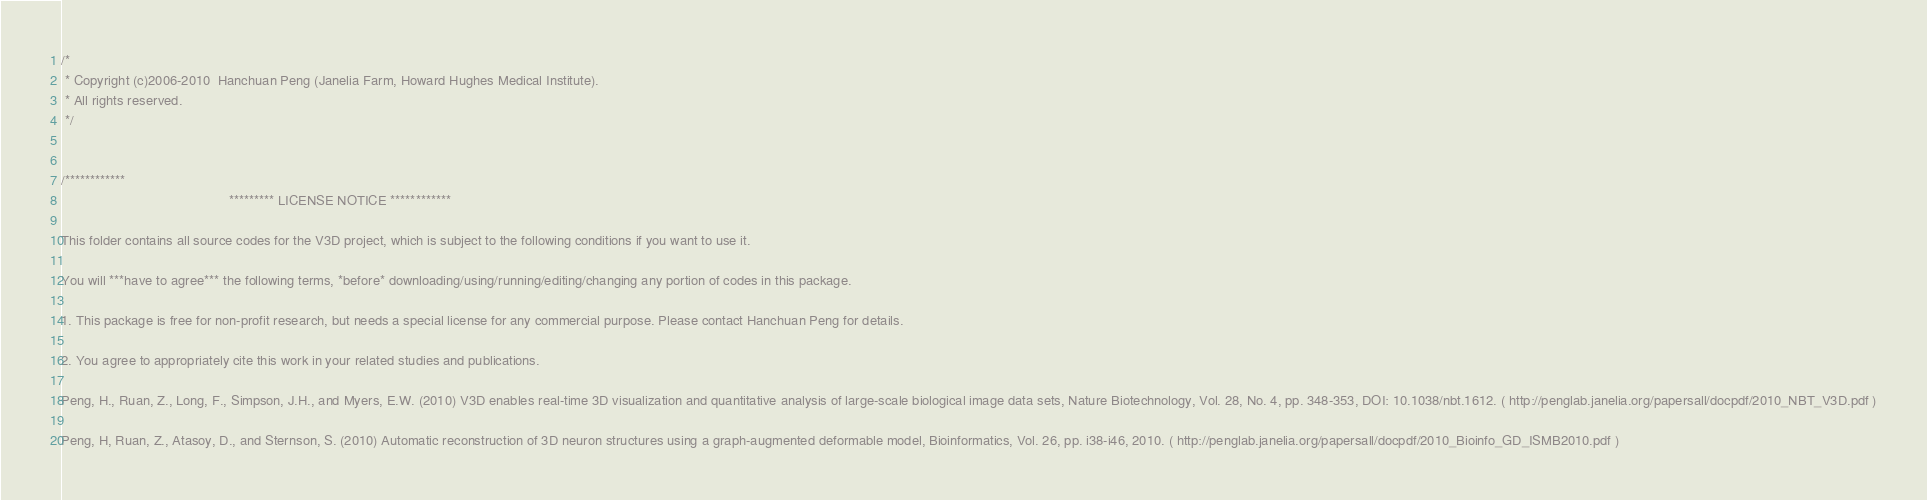<code> <loc_0><loc_0><loc_500><loc_500><_C_>/*
 * Copyright (c)2006-2010  Hanchuan Peng (Janelia Farm, Howard Hughes Medical Institute).
 * All rights reserved.
 */


/************
                                            ********* LICENSE NOTICE ************

This folder contains all source codes for the V3D project, which is subject to the following conditions if you want to use it.

You will ***have to agree*** the following terms, *before* downloading/using/running/editing/changing any portion of codes in this package.

1. This package is free for non-profit research, but needs a special license for any commercial purpose. Please contact Hanchuan Peng for details.

2. You agree to appropriately cite this work in your related studies and publications.

Peng, H., Ruan, Z., Long, F., Simpson, J.H., and Myers, E.W. (2010) V3D enables real-time 3D visualization and quantitative analysis of large-scale biological image data sets, Nature Biotechnology, Vol. 28, No. 4, pp. 348-353, DOI: 10.1038/nbt.1612. ( http://penglab.janelia.org/papersall/docpdf/2010_NBT_V3D.pdf )

Peng, H, Ruan, Z., Atasoy, D., and Sternson, S. (2010) Automatic reconstruction of 3D neuron structures using a graph-augmented deformable model, Bioinformatics, Vol. 26, pp. i38-i46, 2010. ( http://penglab.janelia.org/papersall/docpdf/2010_Bioinfo_GD_ISMB2010.pdf )
</code> 